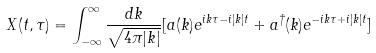<formula> <loc_0><loc_0><loc_500><loc_500>X ( t , \tau ) = \int _ { - \infty } ^ { \infty } \frac { d k } { \sqrt { 4 \pi | k | } } [ a ( k ) e ^ { i k \tau - i | k | t } + a ^ { \dagger } ( k ) e ^ { - i k \tau + i | k | t } ]</formula> 